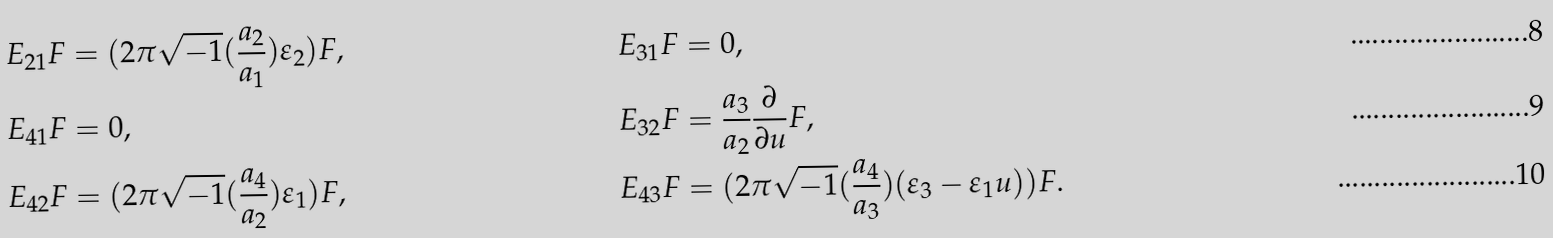Convert formula to latex. <formula><loc_0><loc_0><loc_500><loc_500>E _ { 2 1 } F & = ( 2 \pi \sqrt { - 1 } ( \frac { a _ { 2 } } { a _ { 1 } } ) \varepsilon _ { 2 } ) F , & E _ { 3 1 } F & = 0 , \\ E _ { 4 1 } F & = 0 , & E _ { 3 2 } F & = \frac { a _ { 3 } } { a _ { 2 } } \frac { \partial } { \partial u } F , \\ E _ { 4 2 } F & = ( 2 \pi \sqrt { - 1 } ( \frac { a _ { 4 } } { a _ { 2 } } ) \varepsilon _ { 1 } ) F , & E _ { 4 3 } F & = ( 2 \pi \sqrt { - 1 } ( \frac { a _ { 4 } } { a _ { 3 } } ) ( \varepsilon _ { 3 } - \varepsilon _ { 1 } u ) ) F .</formula> 